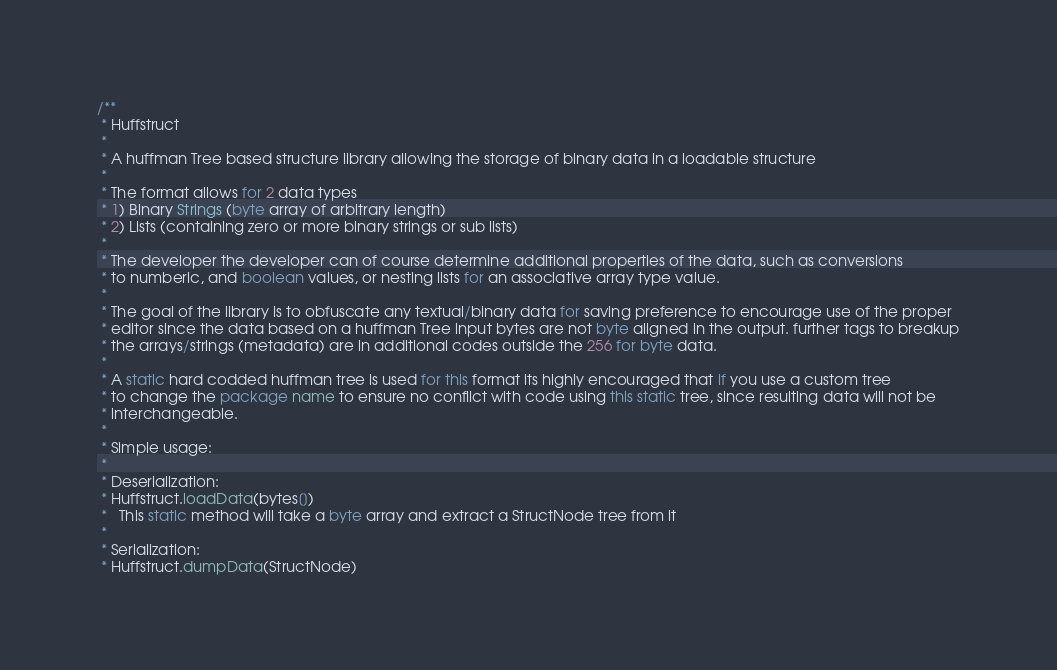<code> <loc_0><loc_0><loc_500><loc_500><_Java_>/**
 * Huffstruct
 *
 * A huffman Tree based structure library allowing the storage of binary data in a loadable structure
 *
 * The format allows for 2 data types
 * 1) Binary Strings (byte array of arbitrary length)
 * 2) Lists (containing zero or more binary strings or sub lists)
 *
 * The developer the developer can of course determine additional properties of the data, such as conversions
 * to numberic, and boolean values, or nesting lists for an associative array type value.
 *
 * The goal of the library is to obfuscate any textual/binary data for saving preference to encourage use of the proper
 * editor since the data based on a huffman Tree input bytes are not byte aligned in the output. further tags to breakup
 * the arrays/strings (metadata) are in additional codes outside the 256 for byte data.
 *
 * A static hard codded huffman tree is used for this format its highly encouraged that if you use a custom tree
 * to change the package name to ensure no conflict with code using this static tree, since resulting data will not be
 * interchangeable.
 *
 * Simple usage:
 *
 * Deserialization:
 * Huffstruct.loadData(bytes[])
 *   This static method will take a byte array and extract a StructNode tree from it
 *
 * Serialization:
 * Huffstruct.dumpData(StructNode)</code> 